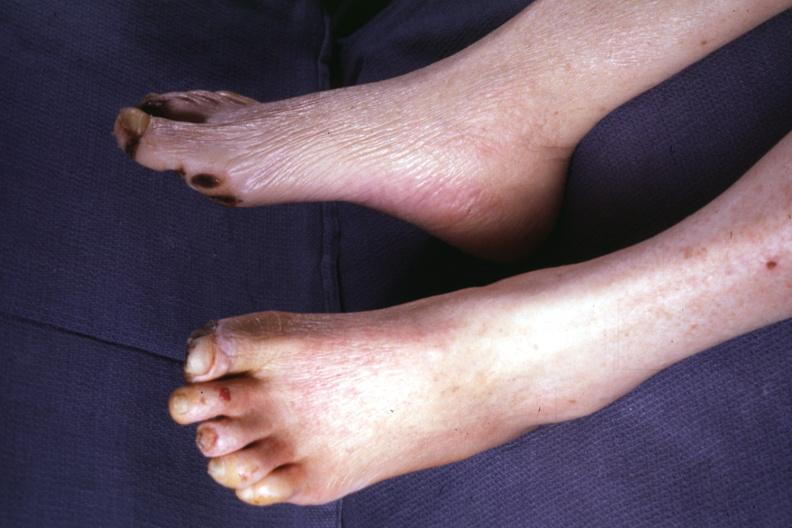what is present?
Answer the question using a single word or phrase. Feet 